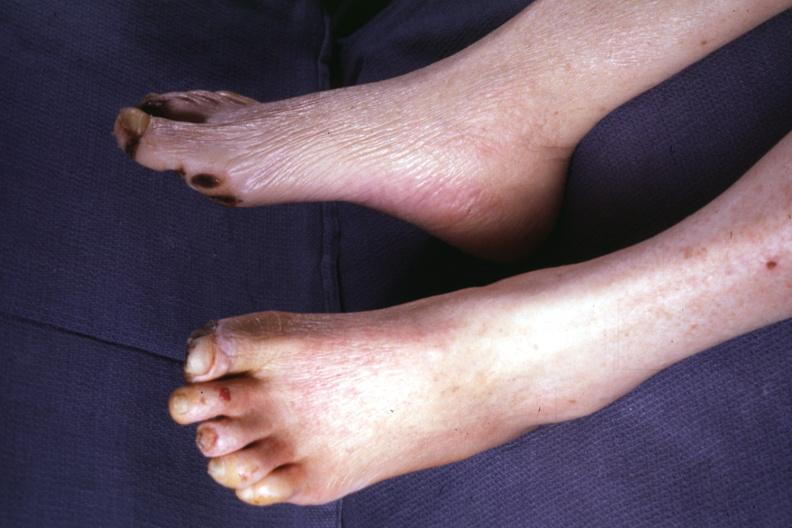what is present?
Answer the question using a single word or phrase. Feet 